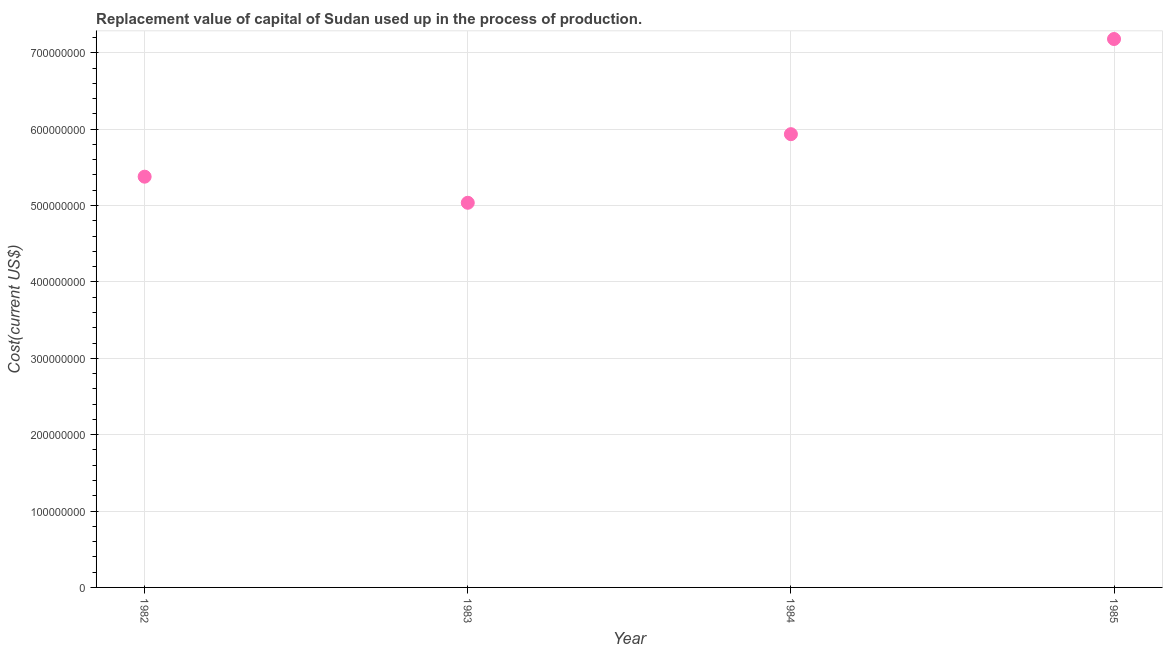What is the consumption of fixed capital in 1984?
Your response must be concise. 5.93e+08. Across all years, what is the maximum consumption of fixed capital?
Provide a succinct answer. 7.18e+08. Across all years, what is the minimum consumption of fixed capital?
Keep it short and to the point. 5.04e+08. In which year was the consumption of fixed capital maximum?
Offer a very short reply. 1985. In which year was the consumption of fixed capital minimum?
Offer a very short reply. 1983. What is the sum of the consumption of fixed capital?
Make the answer very short. 2.35e+09. What is the difference between the consumption of fixed capital in 1982 and 1983?
Offer a terse response. 3.42e+07. What is the average consumption of fixed capital per year?
Offer a terse response. 5.88e+08. What is the median consumption of fixed capital?
Ensure brevity in your answer.  5.66e+08. In how many years, is the consumption of fixed capital greater than 520000000 US$?
Your answer should be compact. 3. What is the ratio of the consumption of fixed capital in 1982 to that in 1985?
Keep it short and to the point. 0.75. Is the difference between the consumption of fixed capital in 1983 and 1984 greater than the difference between any two years?
Give a very brief answer. No. What is the difference between the highest and the second highest consumption of fixed capital?
Your response must be concise. 1.25e+08. What is the difference between the highest and the lowest consumption of fixed capital?
Keep it short and to the point. 2.14e+08. In how many years, is the consumption of fixed capital greater than the average consumption of fixed capital taken over all years?
Make the answer very short. 2. Does the consumption of fixed capital monotonically increase over the years?
Your response must be concise. No. How many dotlines are there?
Give a very brief answer. 1. What is the difference between two consecutive major ticks on the Y-axis?
Ensure brevity in your answer.  1.00e+08. Does the graph contain any zero values?
Your response must be concise. No. Does the graph contain grids?
Offer a very short reply. Yes. What is the title of the graph?
Provide a short and direct response. Replacement value of capital of Sudan used up in the process of production. What is the label or title of the Y-axis?
Your answer should be compact. Cost(current US$). What is the Cost(current US$) in 1982?
Your response must be concise. 5.38e+08. What is the Cost(current US$) in 1983?
Provide a short and direct response. 5.04e+08. What is the Cost(current US$) in 1984?
Your answer should be compact. 5.93e+08. What is the Cost(current US$) in 1985?
Your answer should be compact. 7.18e+08. What is the difference between the Cost(current US$) in 1982 and 1983?
Provide a short and direct response. 3.42e+07. What is the difference between the Cost(current US$) in 1982 and 1984?
Offer a terse response. -5.57e+07. What is the difference between the Cost(current US$) in 1982 and 1985?
Your answer should be compact. -1.80e+08. What is the difference between the Cost(current US$) in 1983 and 1984?
Provide a succinct answer. -8.98e+07. What is the difference between the Cost(current US$) in 1983 and 1985?
Offer a terse response. -2.14e+08. What is the difference between the Cost(current US$) in 1984 and 1985?
Provide a succinct answer. -1.25e+08. What is the ratio of the Cost(current US$) in 1982 to that in 1983?
Provide a succinct answer. 1.07. What is the ratio of the Cost(current US$) in 1982 to that in 1984?
Your answer should be very brief. 0.91. What is the ratio of the Cost(current US$) in 1982 to that in 1985?
Keep it short and to the point. 0.75. What is the ratio of the Cost(current US$) in 1983 to that in 1984?
Give a very brief answer. 0.85. What is the ratio of the Cost(current US$) in 1983 to that in 1985?
Your answer should be very brief. 0.7. What is the ratio of the Cost(current US$) in 1984 to that in 1985?
Your response must be concise. 0.83. 